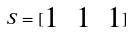Convert formula to latex. <formula><loc_0><loc_0><loc_500><loc_500>S = [ \begin{matrix} 1 & 1 & 1 \end{matrix} ]</formula> 